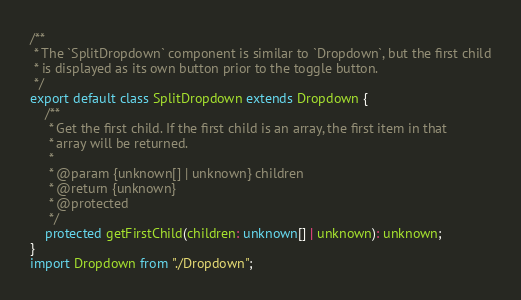Convert code to text. <code><loc_0><loc_0><loc_500><loc_500><_TypeScript_>/**
 * The `SplitDropdown` component is similar to `Dropdown`, but the first child
 * is displayed as its own button prior to the toggle button.
 */
export default class SplitDropdown extends Dropdown {
    /**
     * Get the first child. If the first child is an array, the first item in that
     * array will be returned.
     *
     * @param {unknown[] | unknown} children
     * @return {unknown}
     * @protected
     */
    protected getFirstChild(children: unknown[] | unknown): unknown;
}
import Dropdown from "./Dropdown";
</code> 